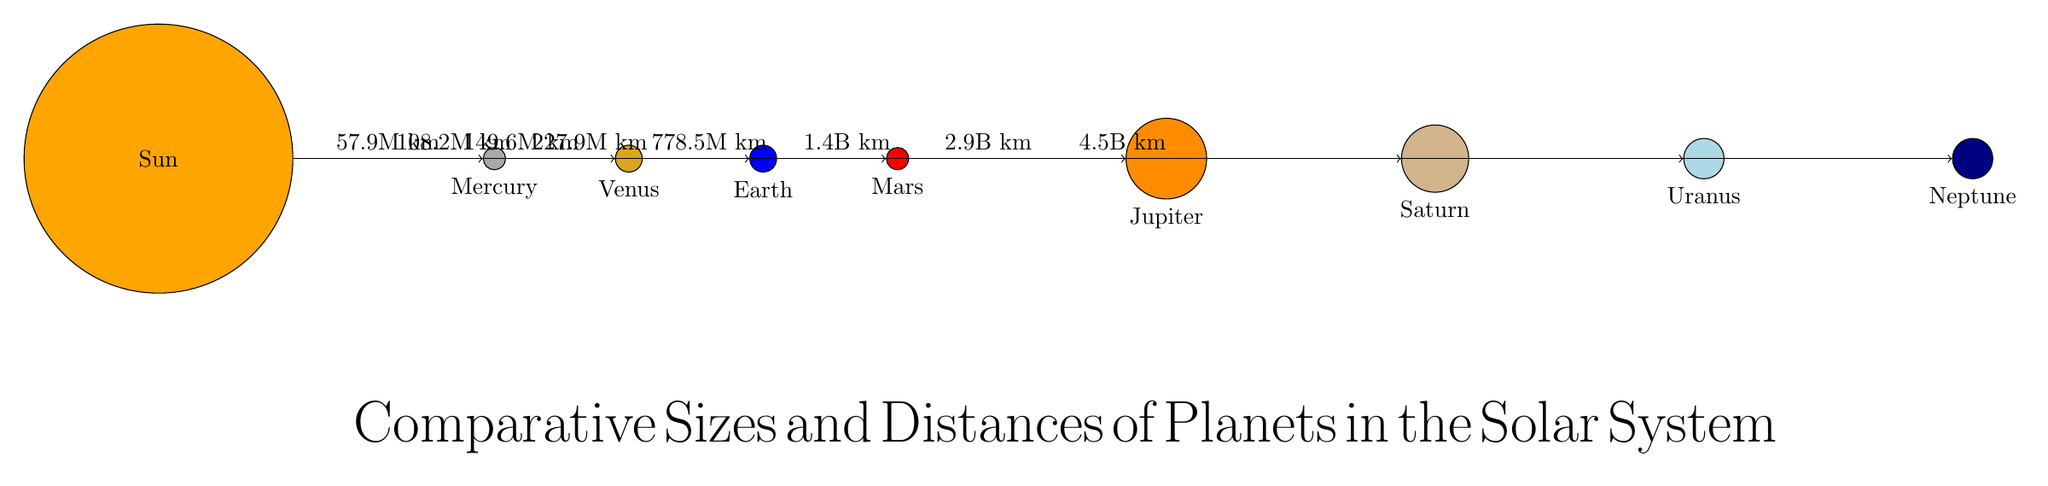What is the distance from the Sun to Mars? The diagram indicates that Mars is at a distance of 227.9 million kilometers from the Sun, which is explicitly shown on the arrow leading from the Sun to Mars.
Answer: 227.9M km Which planet is the largest in the diagram? The size of the planets can be compared visually in the diagram; Jupiter is depicted as the largest planet, as indicated by its minimum size being 1.2 cm, larger than others.
Answer: Jupiter How many planets are shown in the diagram? By counting the labels in the diagram, we can identify the eight planets represented, which are Mercury, Venus, Earth, Mars, Jupiter, Saturn, Uranus, and Neptune.
Answer: 8 What color represents Uranus in the diagram? Each planet is colored distinctly; Uranus is represented in a light blue color, which can be easily identified by looking at the color assigned to its node in the diagram.
Answer: Light blue What is the distance from the Sun to Saturn? The diagram shows Saturn is at a distance of 1.4 billion kilometers from the Sun, indicated on the arrow connecting them. This requires reading the label on the arrow for the correct distance.
Answer: 1.4B km Which planet has the shortest distance from the Sun? By comparing the distances stated on the arrows, Mercury is depicted as being closest to the Sun at 57.9 million kilometers, making it the planet with the shortest distance.
Answer: Mercury What are the colors used for Earth and Mars? The diagram shows Earth is blue and Mars is red; this can be confirmed by checking the colors of their respective circles as illustrated in the diagram.
Answer: Blue and Red How far is Neptune from the Sun? The distance from the Sun to Neptune is indicated as 4.5 billion kilometers on the arrow leading to Neptune, which allows for a straightforward reading of the value.
Answer: 4.5B km 